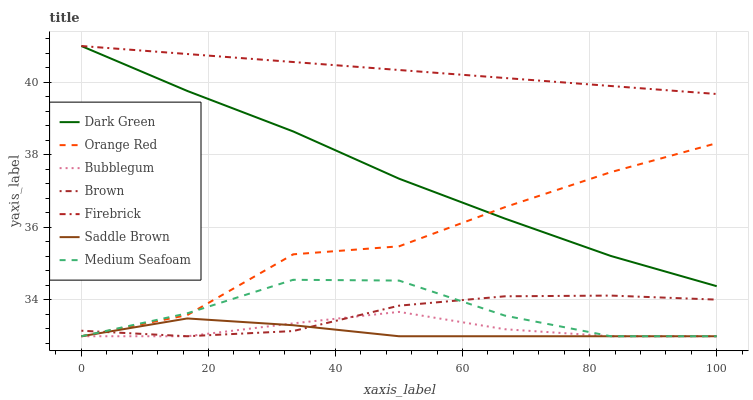Does Saddle Brown have the minimum area under the curve?
Answer yes or no. Yes. Does Firebrick have the maximum area under the curve?
Answer yes or no. Yes. Does Bubblegum have the minimum area under the curve?
Answer yes or no. No. Does Bubblegum have the maximum area under the curve?
Answer yes or no. No. Is Firebrick the smoothest?
Answer yes or no. Yes. Is Orange Red the roughest?
Answer yes or no. Yes. Is Bubblegum the smoothest?
Answer yes or no. No. Is Bubblegum the roughest?
Answer yes or no. No. Does Brown have the lowest value?
Answer yes or no. Yes. Does Firebrick have the lowest value?
Answer yes or no. No. Does Dark Green have the highest value?
Answer yes or no. Yes. Does Bubblegum have the highest value?
Answer yes or no. No. Is Medium Seafoam less than Firebrick?
Answer yes or no. Yes. Is Firebrick greater than Saddle Brown?
Answer yes or no. Yes. Does Bubblegum intersect Brown?
Answer yes or no. Yes. Is Bubblegum less than Brown?
Answer yes or no. No. Is Bubblegum greater than Brown?
Answer yes or no. No. Does Medium Seafoam intersect Firebrick?
Answer yes or no. No. 